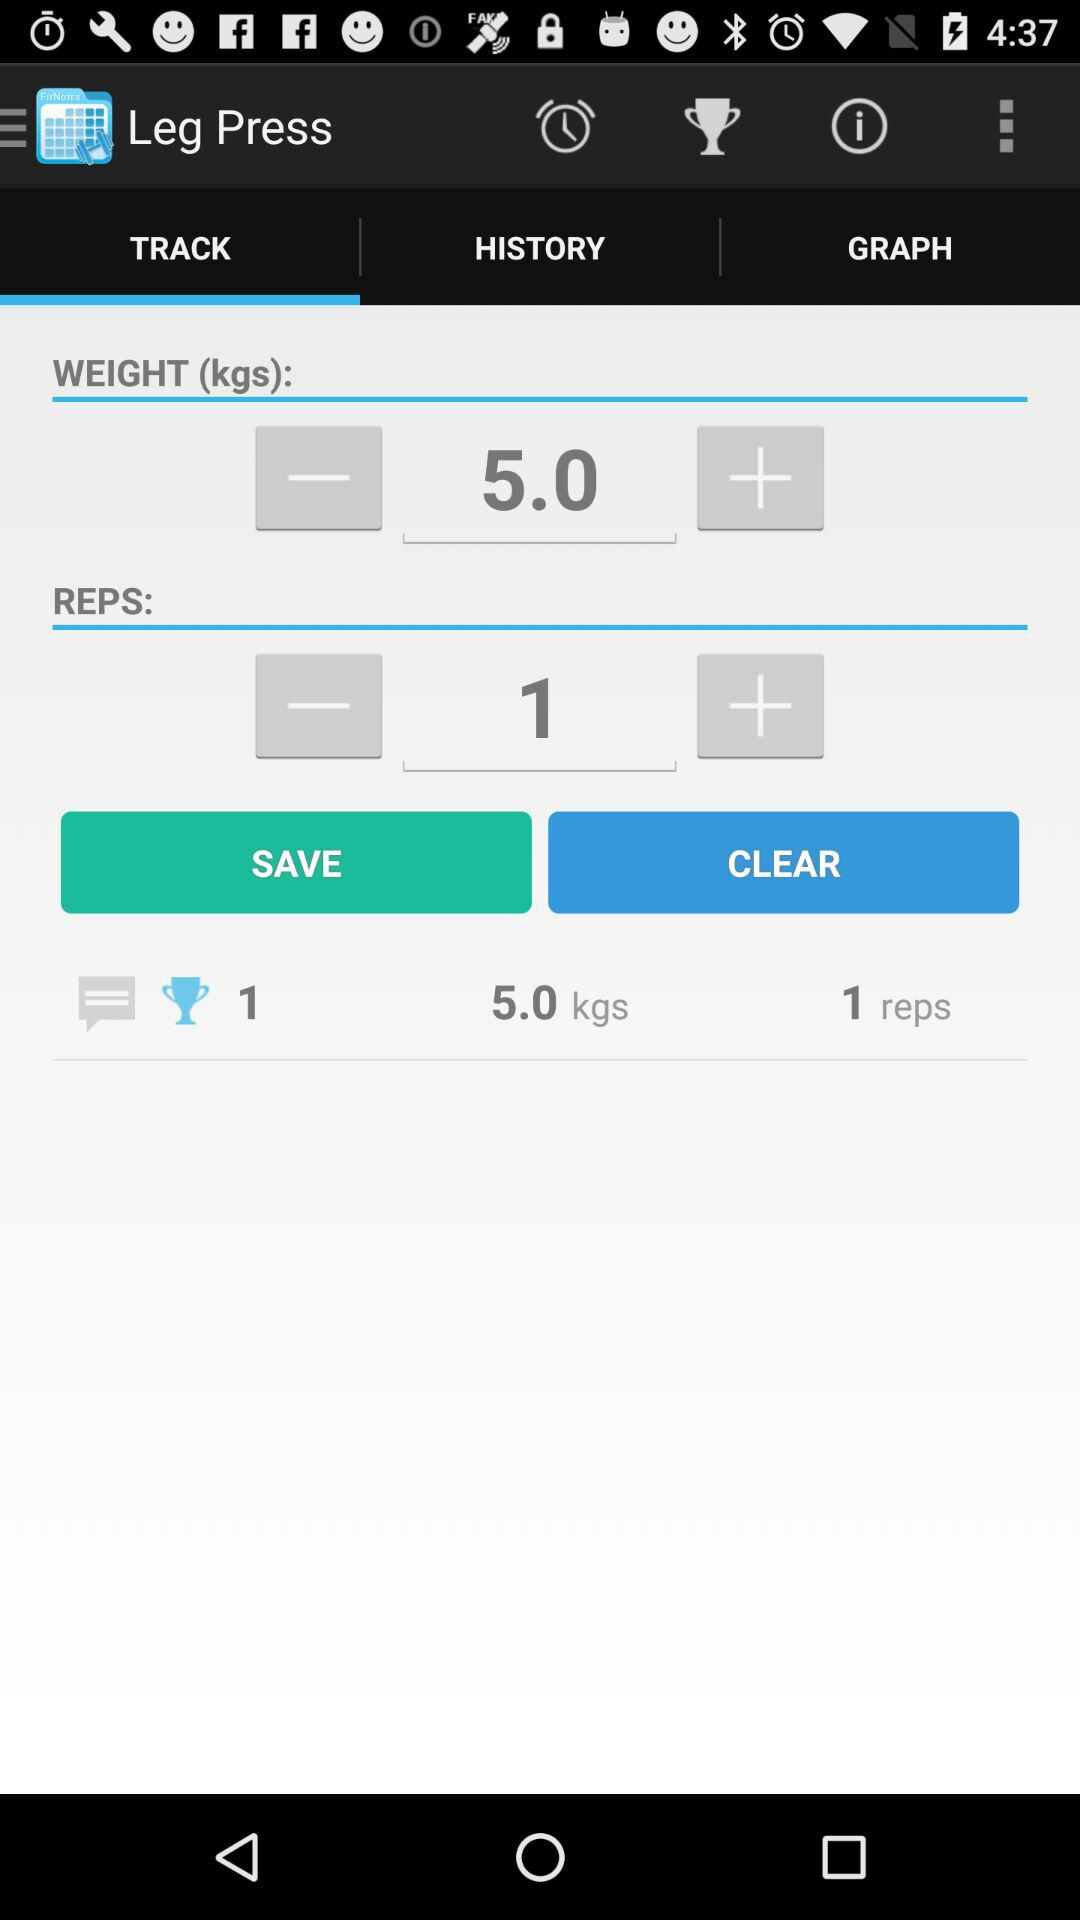What is the weight? The weight is 5 kilograms. 